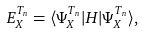Convert formula to latex. <formula><loc_0><loc_0><loc_500><loc_500>E ^ { T _ { n } } _ { X } = \langle \Psi ^ { T _ { n } } _ { X } | { H } | \Psi ^ { T _ { n } } _ { X } \rangle ,</formula> 